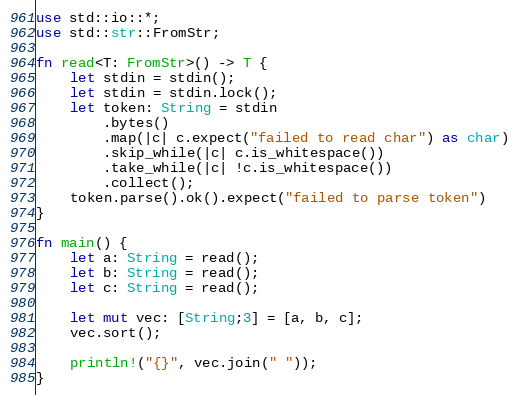Convert code to text. <code><loc_0><loc_0><loc_500><loc_500><_Rust_>use std::io::*;
use std::str::FromStr;

fn read<T: FromStr>() -> T {
    let stdin = stdin();
    let stdin = stdin.lock();
    let token: String = stdin
        .bytes()
        .map(|c| c.expect("failed to read char") as char) 
        .skip_while(|c| c.is_whitespace())
        .take_while(|c| !c.is_whitespace())
        .collect();
    token.parse().ok().expect("failed to parse token")
}

fn main() {
    let a: String = read();
    let b: String = read();
    let c: String = read();

    let mut vec: [String;3] = [a, b, c];
    vec.sort();

    println!("{}", vec.join(" "));
}
</code> 